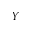Convert formula to latex. <formula><loc_0><loc_0><loc_500><loc_500>Y</formula> 